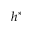<formula> <loc_0><loc_0><loc_500><loc_500>h ^ { * }</formula> 